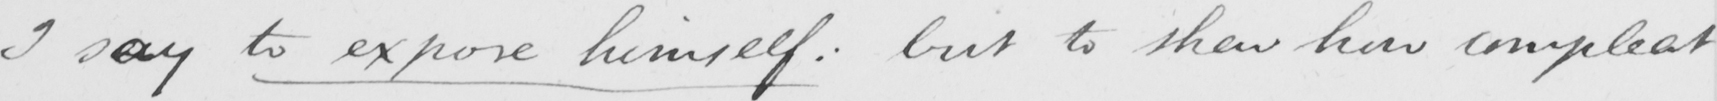Can you tell me what this handwritten text says? I say to expose himself :  but to shew how compleat 